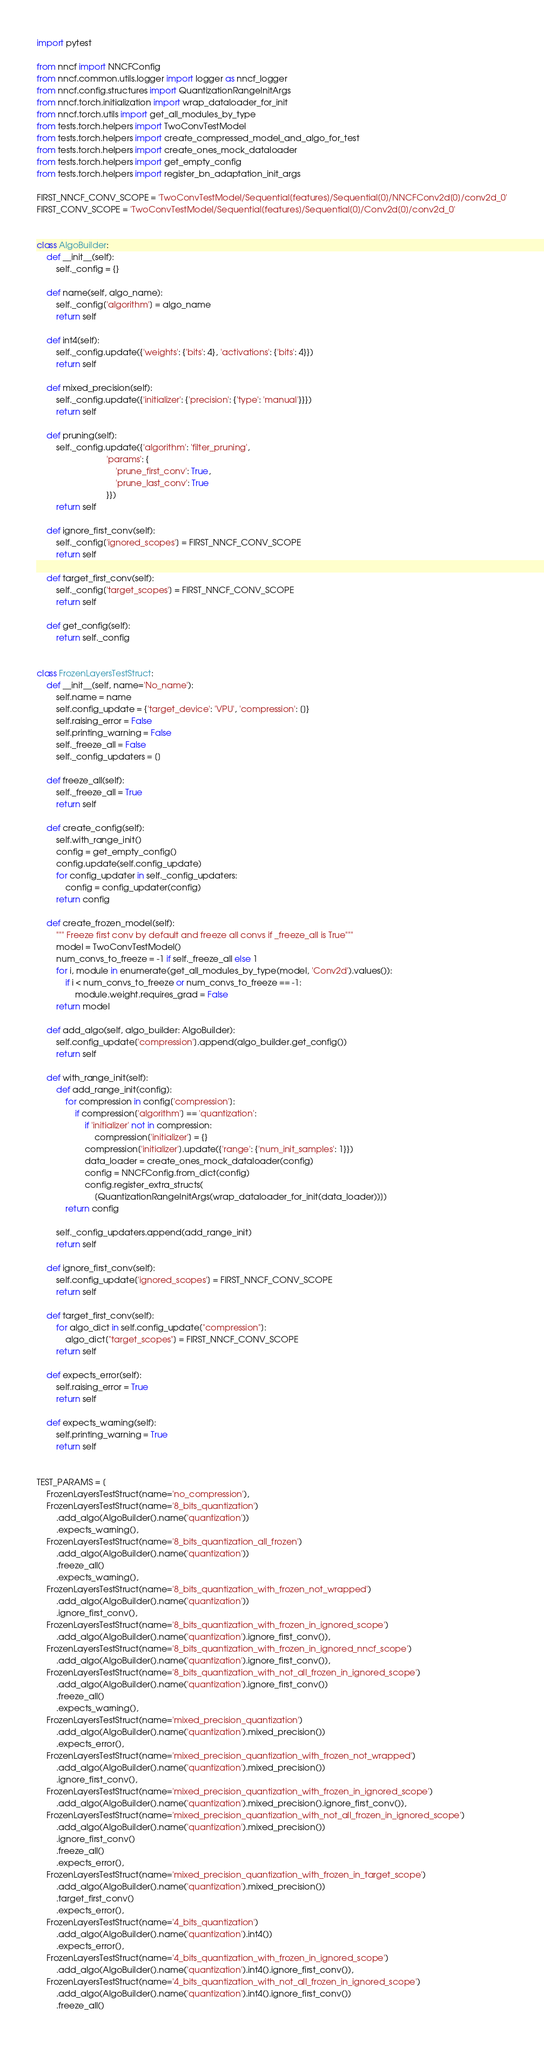Convert code to text. <code><loc_0><loc_0><loc_500><loc_500><_Python_>import pytest

from nncf import NNCFConfig
from nncf.common.utils.logger import logger as nncf_logger
from nncf.config.structures import QuantizationRangeInitArgs
from nncf.torch.initialization import wrap_dataloader_for_init
from nncf.torch.utils import get_all_modules_by_type
from tests.torch.helpers import TwoConvTestModel
from tests.torch.helpers import create_compressed_model_and_algo_for_test
from tests.torch.helpers import create_ones_mock_dataloader
from tests.torch.helpers import get_empty_config
from tests.torch.helpers import register_bn_adaptation_init_args

FIRST_NNCF_CONV_SCOPE = 'TwoConvTestModel/Sequential[features]/Sequential[0]/NNCFConv2d[0]/conv2d_0'
FIRST_CONV_SCOPE = 'TwoConvTestModel/Sequential[features]/Sequential[0]/Conv2d[0]/conv2d_0'


class AlgoBuilder:
    def __init__(self):
        self._config = {}

    def name(self, algo_name):
        self._config['algorithm'] = algo_name
        return self

    def int4(self):
        self._config.update({'weights': {'bits': 4}, 'activations': {'bits': 4}})
        return self

    def mixed_precision(self):
        self._config.update({'initializer': {'precision': {'type': 'manual'}}})
        return self

    def pruning(self):
        self._config.update({'algorithm': 'filter_pruning',
                             'params': {
                                 'prune_first_conv': True,
                                 'prune_last_conv': True
                             }})
        return self

    def ignore_first_conv(self):
        self._config['ignored_scopes'] = FIRST_NNCF_CONV_SCOPE
        return self

    def target_first_conv(self):
        self._config['target_scopes'] = FIRST_NNCF_CONV_SCOPE
        return self

    def get_config(self):
        return self._config


class FrozenLayersTestStruct:
    def __init__(self, name='No_name'):
        self.name = name
        self.config_update = {'target_device': 'VPU', 'compression': []}
        self.raising_error = False
        self.printing_warning = False
        self._freeze_all = False
        self._config_updaters = []

    def freeze_all(self):
        self._freeze_all = True
        return self

    def create_config(self):
        self.with_range_init()
        config = get_empty_config()
        config.update(self.config_update)
        for config_updater in self._config_updaters:
            config = config_updater(config)
        return config

    def create_frozen_model(self):
        """ Freeze first conv by default and freeze all convs if _freeze_all is True"""
        model = TwoConvTestModel()
        num_convs_to_freeze = -1 if self._freeze_all else 1
        for i, module in enumerate(get_all_modules_by_type(model, 'Conv2d').values()):
            if i < num_convs_to_freeze or num_convs_to_freeze == -1:
                module.weight.requires_grad = False
        return model

    def add_algo(self, algo_builder: AlgoBuilder):
        self.config_update['compression'].append(algo_builder.get_config())
        return self

    def with_range_init(self):
        def add_range_init(config):
            for compression in config['compression']:
                if compression['algorithm'] == 'quantization':
                    if 'initializer' not in compression:
                        compression['initializer'] = {}
                    compression['initializer'].update({'range': {'num_init_samples': 1}})
                    data_loader = create_ones_mock_dataloader(config)
                    config = NNCFConfig.from_dict(config)
                    config.register_extra_structs(
                        [QuantizationRangeInitArgs(wrap_dataloader_for_init(data_loader))])
            return config

        self._config_updaters.append(add_range_init)
        return self

    def ignore_first_conv(self):
        self.config_update['ignored_scopes'] = FIRST_NNCF_CONV_SCOPE
        return self

    def target_first_conv(self):
        for algo_dict in self.config_update["compression"]:
            algo_dict["target_scopes"] = FIRST_NNCF_CONV_SCOPE
        return self

    def expects_error(self):
        self.raising_error = True
        return self

    def expects_warning(self):
        self.printing_warning = True
        return self


TEST_PARAMS = [
    FrozenLayersTestStruct(name='no_compression'),
    FrozenLayersTestStruct(name='8_bits_quantization')
        .add_algo(AlgoBuilder().name('quantization'))
        .expects_warning(),
    FrozenLayersTestStruct(name='8_bits_quantization_all_frozen')
        .add_algo(AlgoBuilder().name('quantization'))
        .freeze_all()
        .expects_warning(),
    FrozenLayersTestStruct(name='8_bits_quantization_with_frozen_not_wrapped')
        .add_algo(AlgoBuilder().name('quantization'))
        .ignore_first_conv(),
    FrozenLayersTestStruct(name='8_bits_quantization_with_frozen_in_ignored_scope')
        .add_algo(AlgoBuilder().name('quantization').ignore_first_conv()),
    FrozenLayersTestStruct(name='8_bits_quantization_with_frozen_in_ignored_nncf_scope')
        .add_algo(AlgoBuilder().name('quantization').ignore_first_conv()),
    FrozenLayersTestStruct(name='8_bits_quantization_with_not_all_frozen_in_ignored_scope')
        .add_algo(AlgoBuilder().name('quantization').ignore_first_conv())
        .freeze_all()
        .expects_warning(),
    FrozenLayersTestStruct(name='mixed_precision_quantization')
        .add_algo(AlgoBuilder().name('quantization').mixed_precision())
        .expects_error(),
    FrozenLayersTestStruct(name='mixed_precision_quantization_with_frozen_not_wrapped')
        .add_algo(AlgoBuilder().name('quantization').mixed_precision())
        .ignore_first_conv(),
    FrozenLayersTestStruct(name='mixed_precision_quantization_with_frozen_in_ignored_scope')
        .add_algo(AlgoBuilder().name('quantization').mixed_precision().ignore_first_conv()),
    FrozenLayersTestStruct(name='mixed_precision_quantization_with_not_all_frozen_in_ignored_scope')
        .add_algo(AlgoBuilder().name('quantization').mixed_precision())
        .ignore_first_conv()
        .freeze_all()
        .expects_error(),
    FrozenLayersTestStruct(name='mixed_precision_quantization_with_frozen_in_target_scope')
        .add_algo(AlgoBuilder().name('quantization').mixed_precision())
        .target_first_conv()
        .expects_error(),
    FrozenLayersTestStruct(name='4_bits_quantization')
        .add_algo(AlgoBuilder().name('quantization').int4())
        .expects_error(),
    FrozenLayersTestStruct(name='4_bits_quantization_with_frozen_in_ignored_scope')
        .add_algo(AlgoBuilder().name('quantization').int4().ignore_first_conv()),
    FrozenLayersTestStruct(name='4_bits_quantization_with_not_all_frozen_in_ignored_scope')
        .add_algo(AlgoBuilder().name('quantization').int4().ignore_first_conv())
        .freeze_all()</code> 